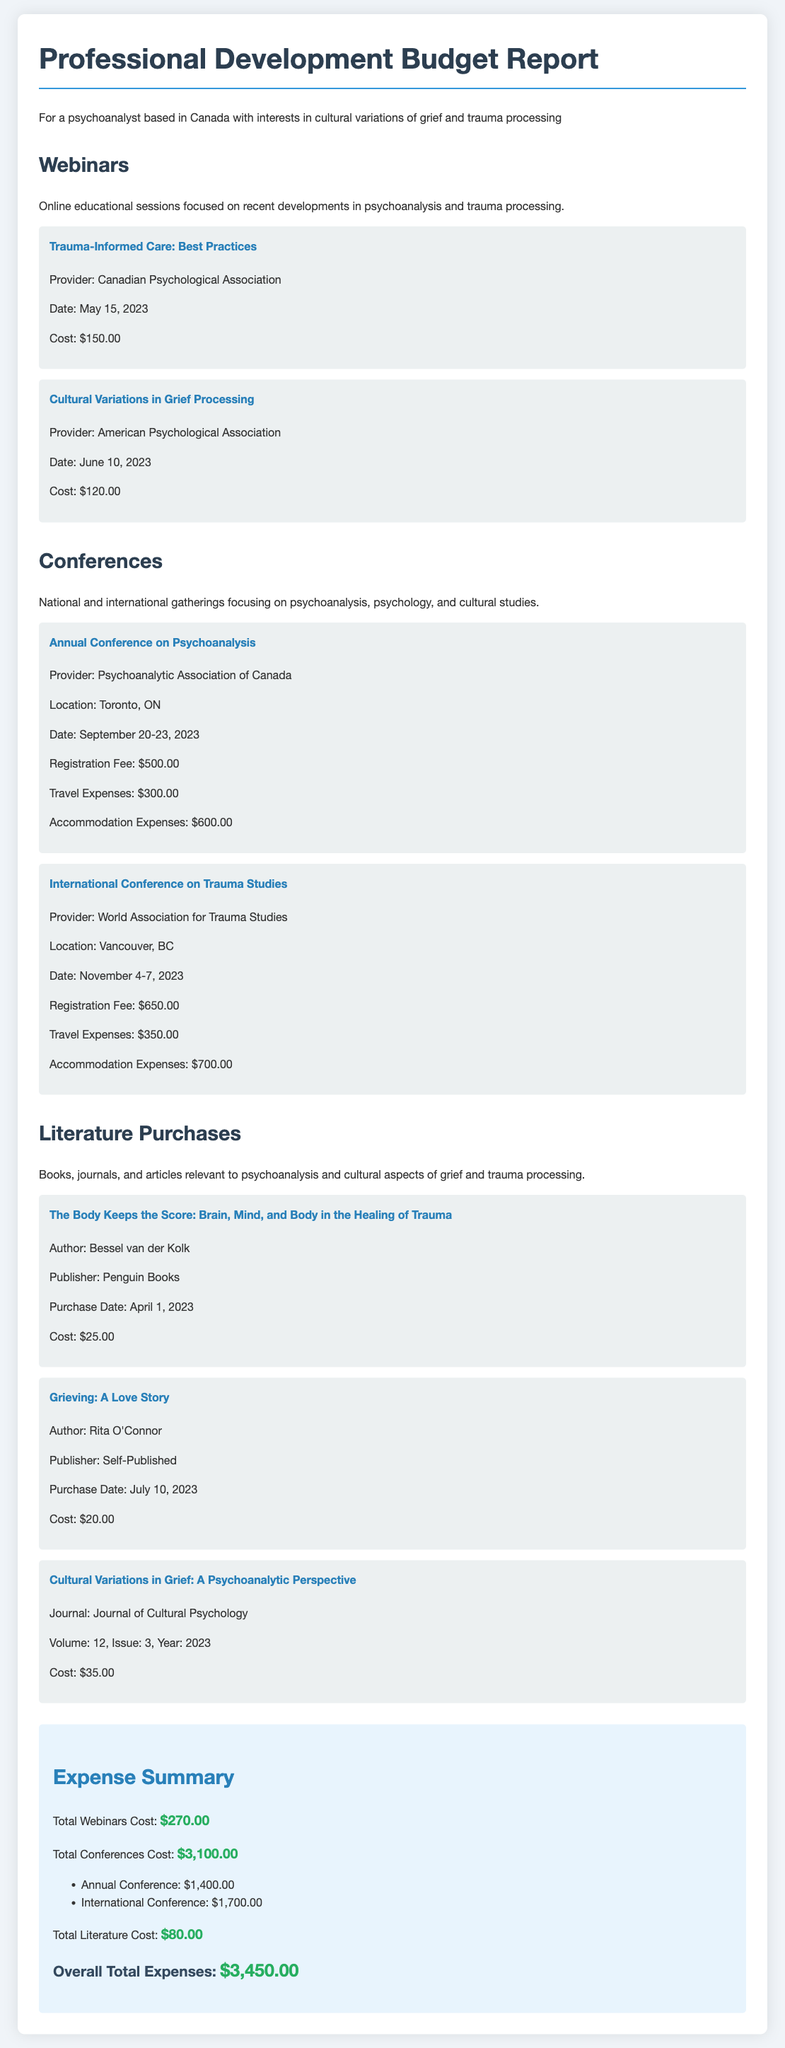What is the total cost for webinars? The total cost for webinars is listed at the end of the section and amounts to $270.00.
Answer: $270.00 Who provided the "Cultural Variations in Grief Processing" webinar? The provider of this webinar is mentioned in the expense item details, which is the American Psychological Association.
Answer: American Psychological Association What is the location of the "Annual Conference on Psychoanalysis"? The location is specified in the conference expense details, which is Toronto, ON.
Answer: Toronto, ON How much was spent on accommodation for the "International Conference on Trauma Studies"? The expense item details indicate that the accommodation expenses are $700.00.
Answer: $700.00 Which book was purchased on April 1, 2023? The purchase date for this book is specified, which is "The Body Keeps the Score: Brain, Mind, and Body in the Healing of Trauma".
Answer: The Body Keeps the Score: Brain, Mind, and Body in the Healing of Trauma What is the overall total expenses? The overall total expenses are provided in the summary section, which adds up to $3,450.00.
Answer: $3,450.00 What was the travel expense for the "Annual Conference on Psychoanalysis"? The travel expenses for this conference are detailed in the document, which is $300.00.
Answer: $300.00 How many literature items were purchased? The literature section lists three different items that were purchased.
Answer: Three What was the cost of the "Grieving: A Love Story"? The cost for this specific literature item is provided as $20.00.
Answer: $20.00 